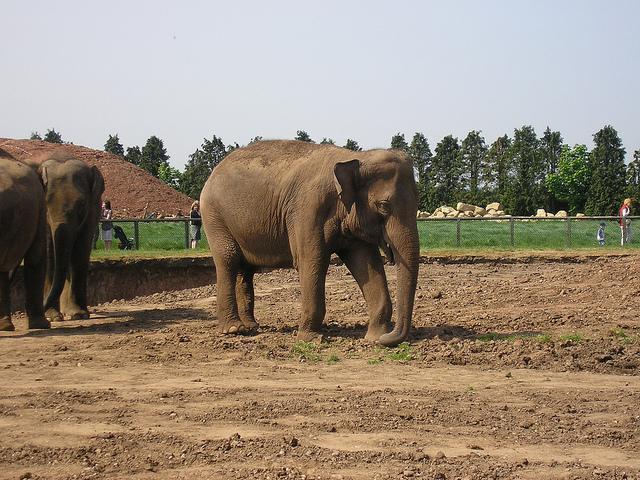Why do people gather outside the fence?
Select the accurate answer and provide explanation: 'Answer: answer
Rationale: rationale.'
Options: Elephant rides, resting, waiting bus, watch elephants. Answer: watch elephants.
Rationale: The people are observing the elephants at a zoo. 